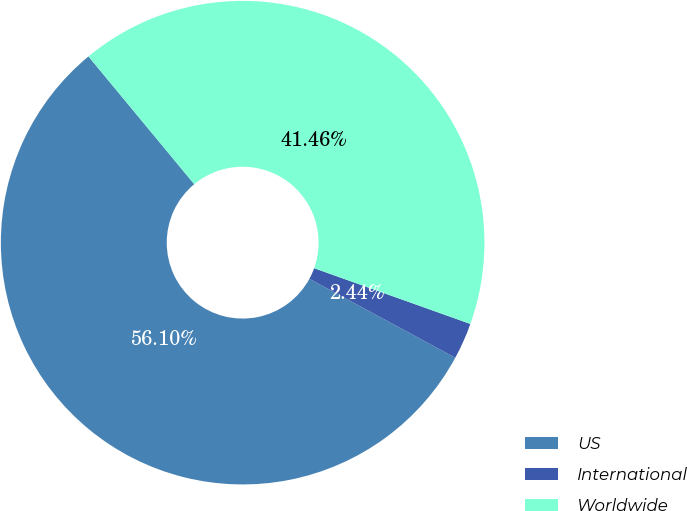Convert chart. <chart><loc_0><loc_0><loc_500><loc_500><pie_chart><fcel>US<fcel>International<fcel>Worldwide<nl><fcel>56.1%<fcel>2.44%<fcel>41.46%<nl></chart> 